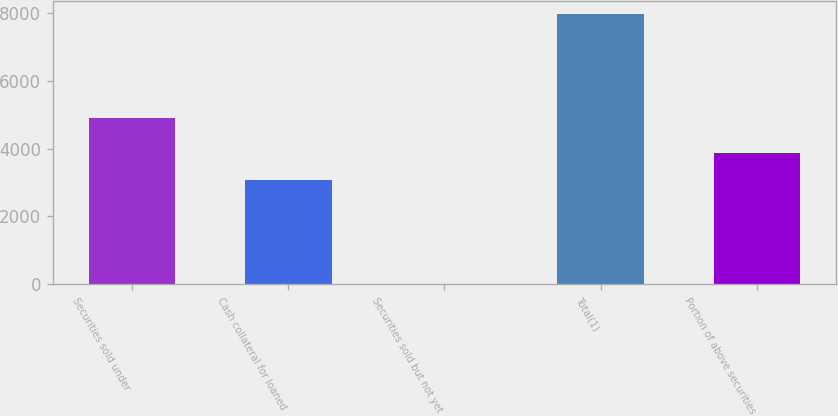<chart> <loc_0><loc_0><loc_500><loc_500><bar_chart><fcel>Securities sold under<fcel>Cash collateral for loaned<fcel>Securities sold but not yet<fcel>Total(1)<fcel>Portion of above securities<nl><fcel>4906<fcel>3057<fcel>2<fcel>7965<fcel>3853.3<nl></chart> 